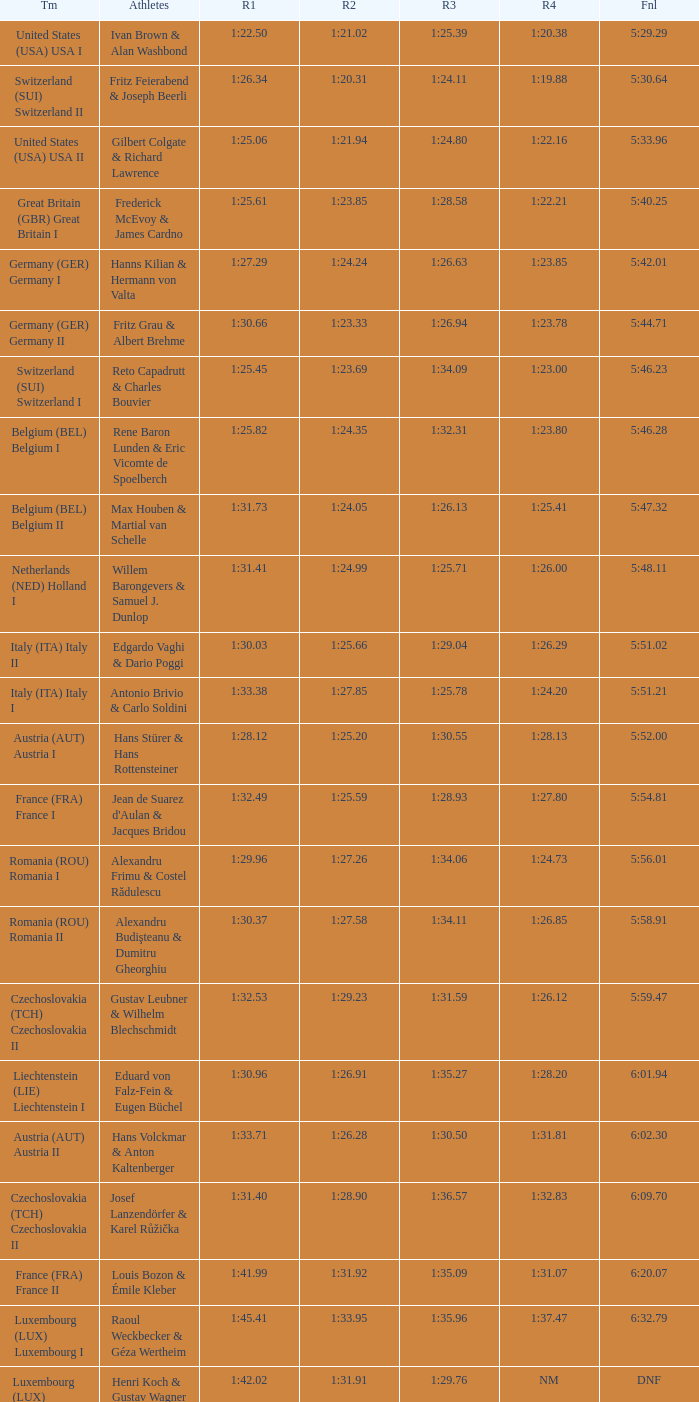Which Run 4 has a Run 3 of 1:26.63? 1:23.85. 